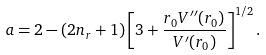<formula> <loc_0><loc_0><loc_500><loc_500>a = 2 - ( 2 n _ { r } + 1 ) \left [ 3 + \frac { r _ { 0 } V ^ { \prime \prime } ( r _ { 0 } ) } { V ^ { \prime } ( r _ { 0 } ) } \right ] ^ { 1 / 2 } .</formula> 